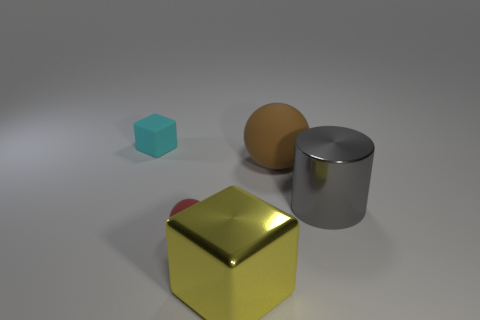Add 3 tiny cyan rubber cylinders. How many objects exist? 8 Subtract all balls. How many objects are left? 3 Add 2 shiny cylinders. How many shiny cylinders exist? 3 Subtract 0 cyan cylinders. How many objects are left? 5 Subtract all matte objects. Subtract all large cubes. How many objects are left? 1 Add 1 small red matte objects. How many small red matte objects are left? 2 